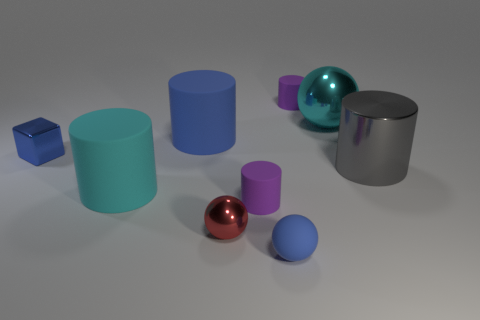Subtract all large gray cylinders. How many cylinders are left? 4 Subtract all blue cylinders. How many cylinders are left? 4 Subtract all red cylinders. Subtract all green blocks. How many cylinders are left? 5 Subtract all blocks. How many objects are left? 8 Subtract 0 gray blocks. How many objects are left? 9 Subtract all big blue metallic things. Subtract all small rubber balls. How many objects are left? 8 Add 8 tiny red shiny objects. How many tiny red shiny objects are left? 9 Add 5 red metal things. How many red metal things exist? 6 